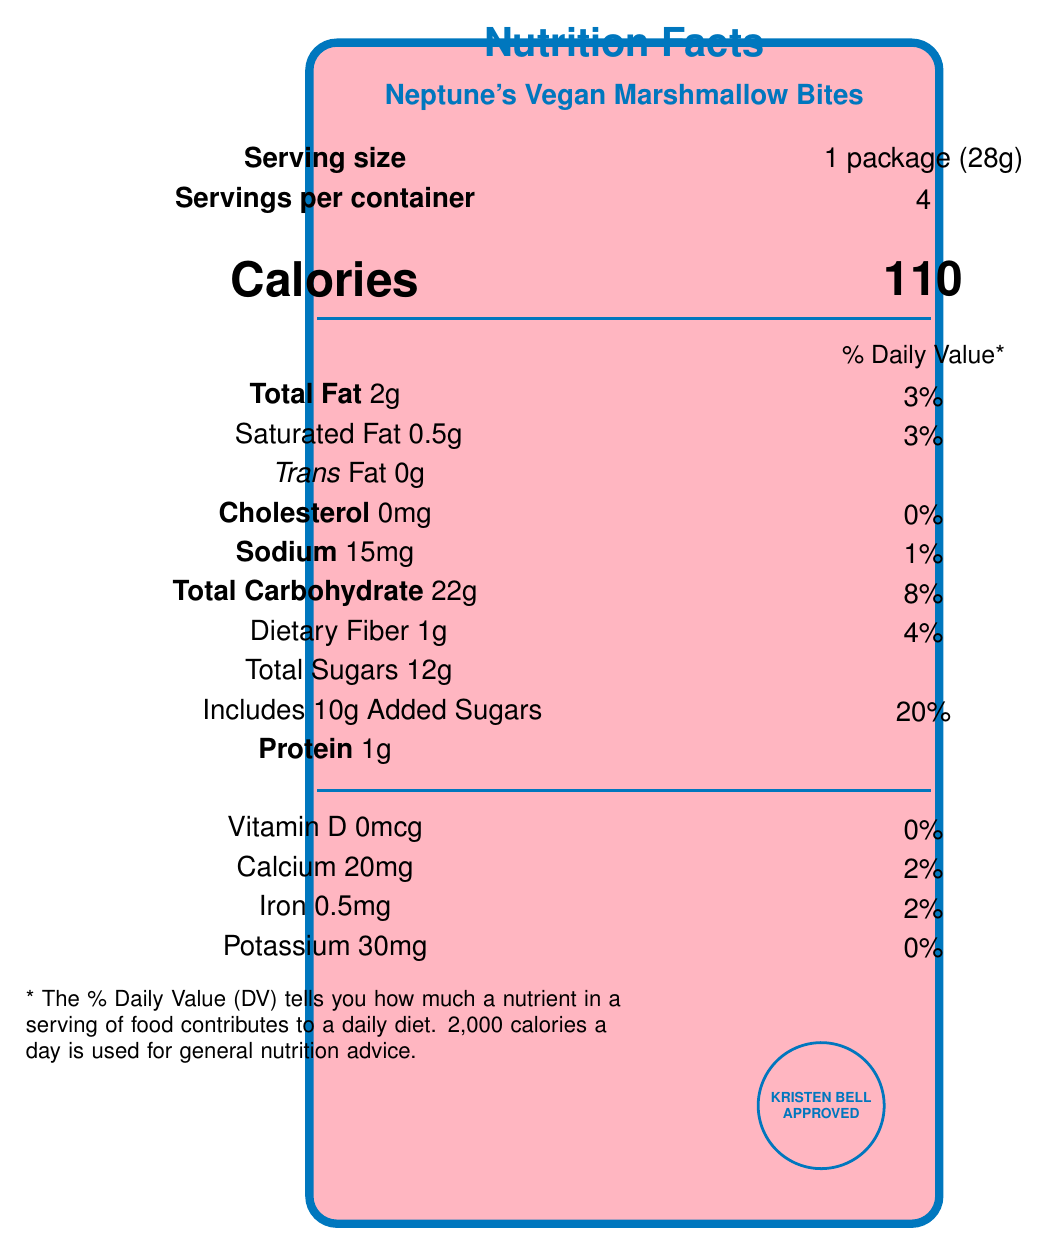What is the serving size for Neptune's Vegan Marshmallow Bites? The document explicitly states that the serving size is "1 package (28g)".
Answer: 1 package (28g) How many servings are there per container? The document lists "Servings per container" as 4.
Answer: 4 How many calories are in one serving? Under the "Calories" section, it states there are 110 calories per serving.
Answer: 110 What is the total amount of sugars per serving? The total amount of sugars is listed as 12g in the nutrient information.
Answer: 12g What percentage of the daily value for added sugars does one serving of Neptune's Vegan Marshmallow Bites contain? The document indicates that the added sugars constitute 20% of the daily value.
Answer: 20% Which ingredient is sourced from the Dog Beach in Neptune? A. Organic cane sugar B. Carrageenan C. Organic tapioca syrup D. Organic vanilla extract The ingredients list mentions that "Organic tapioca syrup" is sourced from Dog Beach, Neptune.
Answer: C What is the sodium content per serving? A. 10mg B. 15mg C. 20mg D. 25mg According to the document, the sodium content per serving is 15mg.
Answer: B Is the product vegan? The document includes "Vegan" in its certified claims.
Answer: Yes Summarize the main idea of the Nutrition Facts Label for Neptune's Vegan Marshmallow Bites. The main idea is clearly laid out in the marketing description and nutrient facts, highlighting its vegan nature, Kristen Bell's approval, and ingredient origins.
Answer: Neptune's Vegan Marshmallow Bites are a Kristen Bell-approved vegan snack with ingredients sourced from iconic locations in Neptune, California. Each serving (one package) contains 110 calories, 2g of total fat, 22g of carbohydrates, and 1g of protein. The product is also Non-GMO Project Verified, gluten-free, and produced in a facility that processes tree nuts and soy. Where is the organic vanilla extract sourced from? The ingredients list specifies that the organic vanilla extract is sourced from Hearst College campus garden.
Answer: Hearst College campus garden Does one serving contain Vitamin D? The document states that Vitamin D is 0mcg per serving, contributing 0% to the daily value.
Answer: No What company manufactures Neptune's Vegan Marshmallow Bites? The document lists "Mars Investigations Snack Co., Neptune, CA" as the manufacturer.
Answer: Mars Investigations Snack Co. What are the certified claims listed for Neptune's Vegan Marshmallow Bites? The document mentions these claims explicitly as part of its certification.
Answer: Vegan, Non-GMO Project Verified, Gluten-Free, Kristen Bell Approved What is the total fat percentage of daily value per serving? It states that the total fat content of 2g per serving accounts for 3% of the daily value.
Answer: 3% How much protein is in one serving? The document lists 1g of protein per serving under the nutrient information.
Answer: 1g Where can you find more information about Neptune's Vegan Marshmallow Bites? The document provides this website for more information.
Answer: www.neptunevegantreats.com What is the color of the border of the Nutrition Facts Label? The stitching code specifies “neptuneblue” for the border color.
Answer: Blue What year was Kristen Bell born? The document does not provide information about Kristen Bell's birth year.
Answer: Cannot be determined 